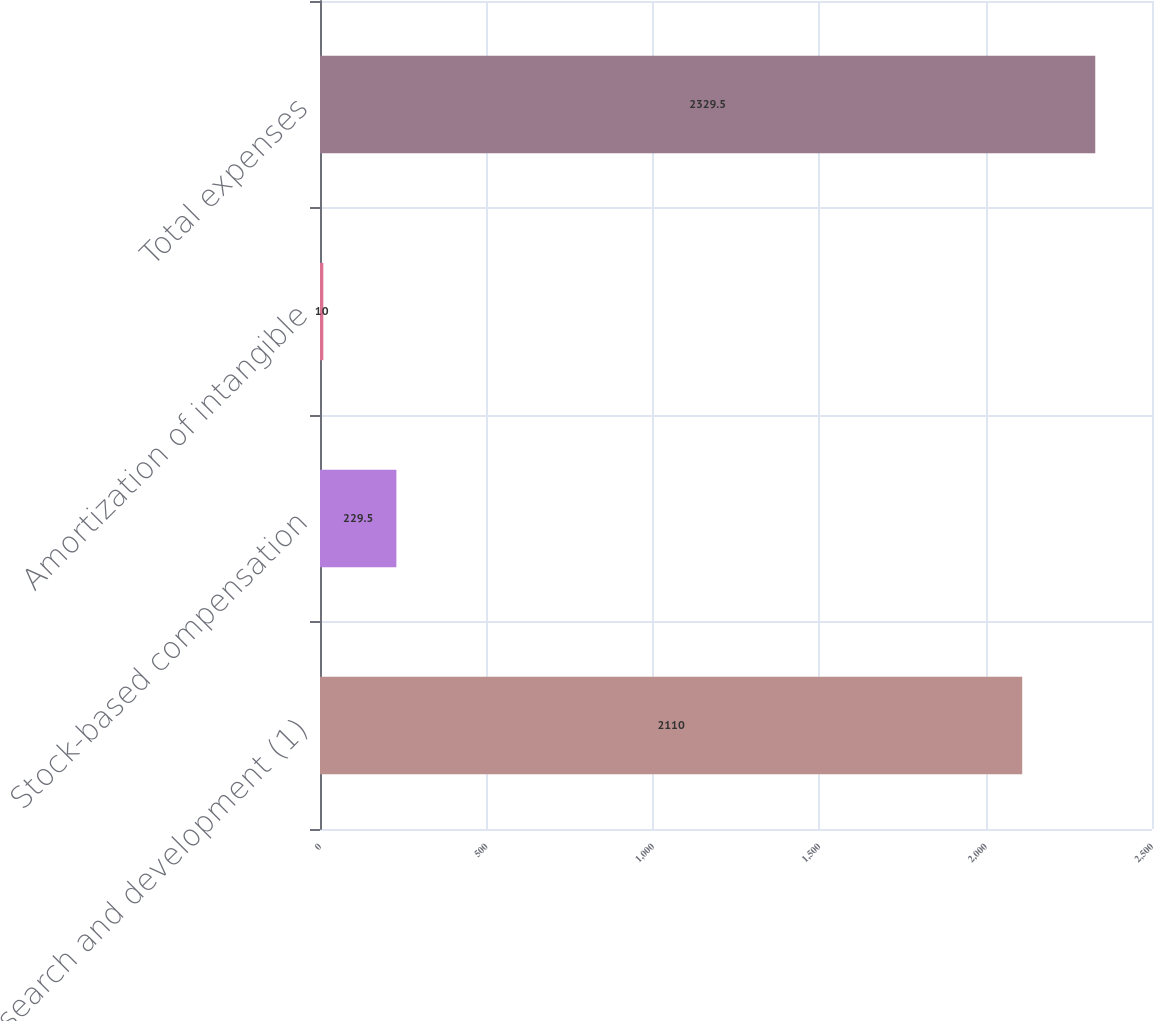Convert chart to OTSL. <chart><loc_0><loc_0><loc_500><loc_500><bar_chart><fcel>Research and development (1)<fcel>Stock-based compensation<fcel>Amortization of intangible<fcel>Total expenses<nl><fcel>2110<fcel>229.5<fcel>10<fcel>2329.5<nl></chart> 